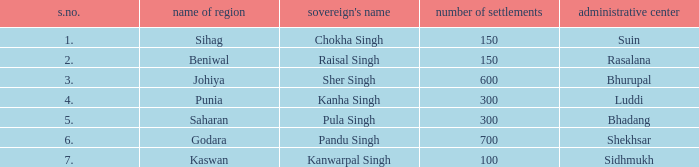What is the average number of villages with a name of janapada of Punia? 300.0. 